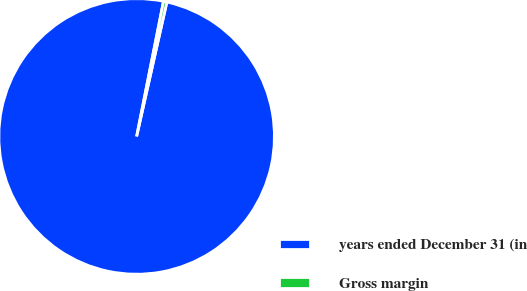Convert chart. <chart><loc_0><loc_0><loc_500><loc_500><pie_chart><fcel>years ended December 31 (in<fcel>Gross margin<nl><fcel>99.6%<fcel>0.4%<nl></chart> 